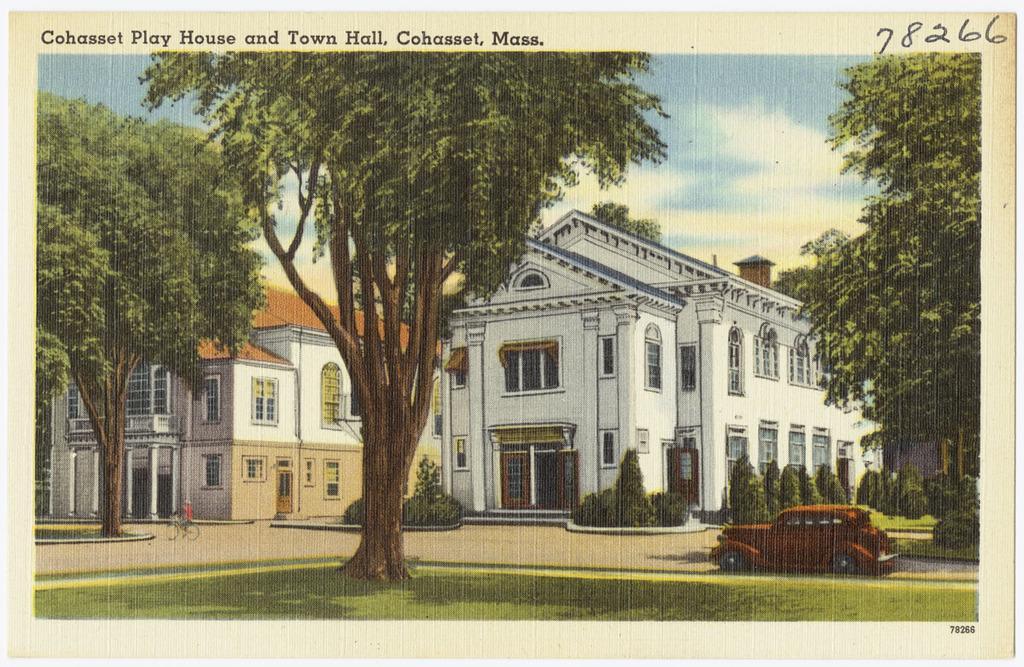Could you give a brief overview of what you see in this image? In this picture we can see the grass, car on the ground and a person on a bicycle, trees, some text, buildings with windows and in the background we can see the sky. 